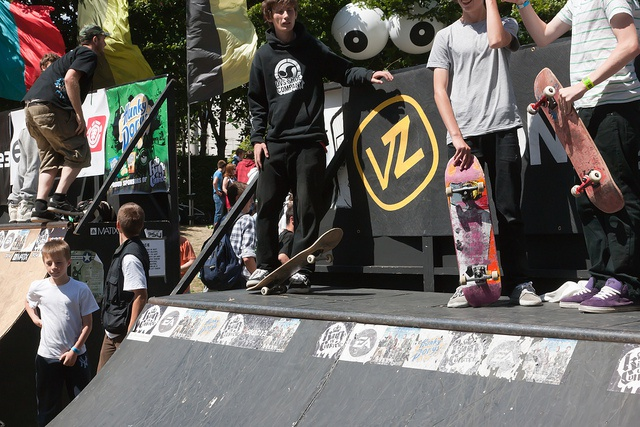Describe the objects in this image and their specific colors. I can see people in lightblue, black, lightgray, and gray tones, people in lightblue, black, gray, lightgray, and maroon tones, people in lightblue, black, lightgray, gray, and darkgray tones, people in lightblue, black, gray, and maroon tones, and people in lightblue, black, lightgray, and gray tones in this image. 